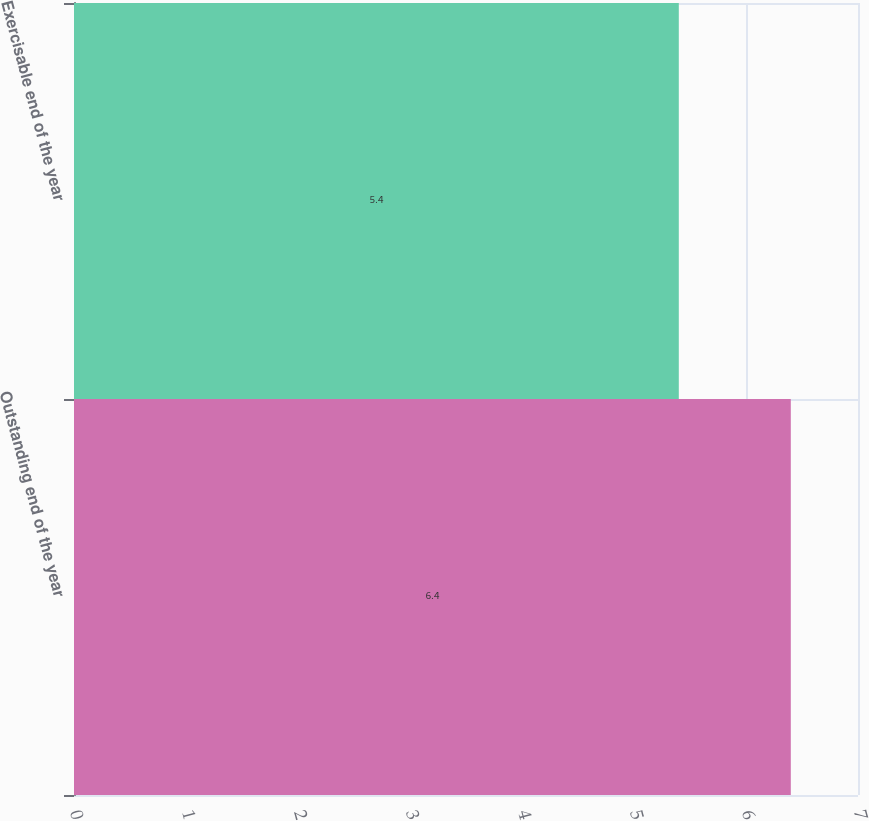Convert chart. <chart><loc_0><loc_0><loc_500><loc_500><bar_chart><fcel>Outstanding end of the year<fcel>Exercisable end of the year<nl><fcel>6.4<fcel>5.4<nl></chart> 